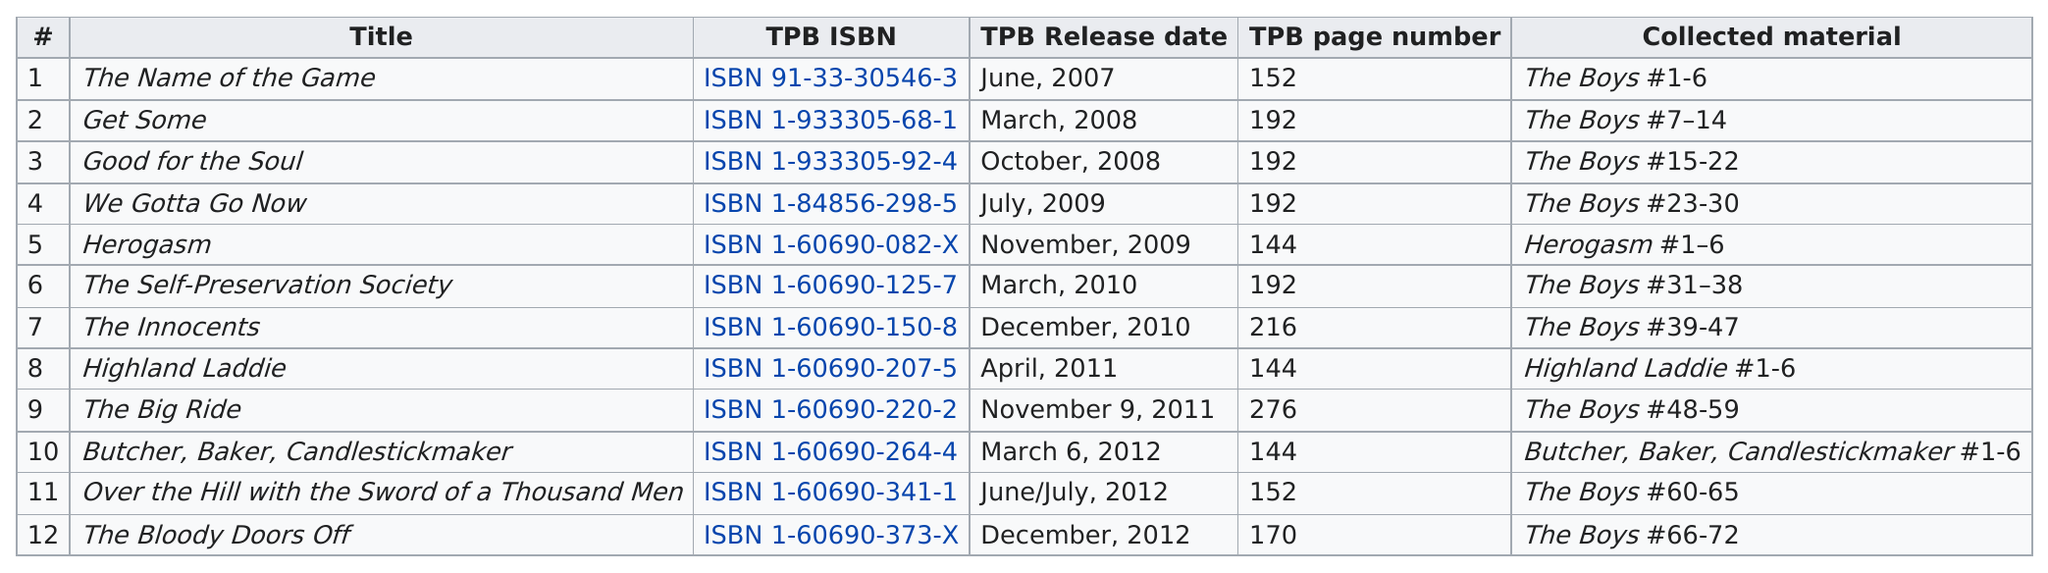List a handful of essential elements in this visual. The Highland Laddie collection was the one that exceeded the expectations, it was above the big ride The collection that topped the list is The Name of the Game. In March or April of any given year, a total of 4 were released. Thirty-three individuals who were not part of 'the boys' collected materials. As of 2009, there have been 7 releases subsequent to that year. 